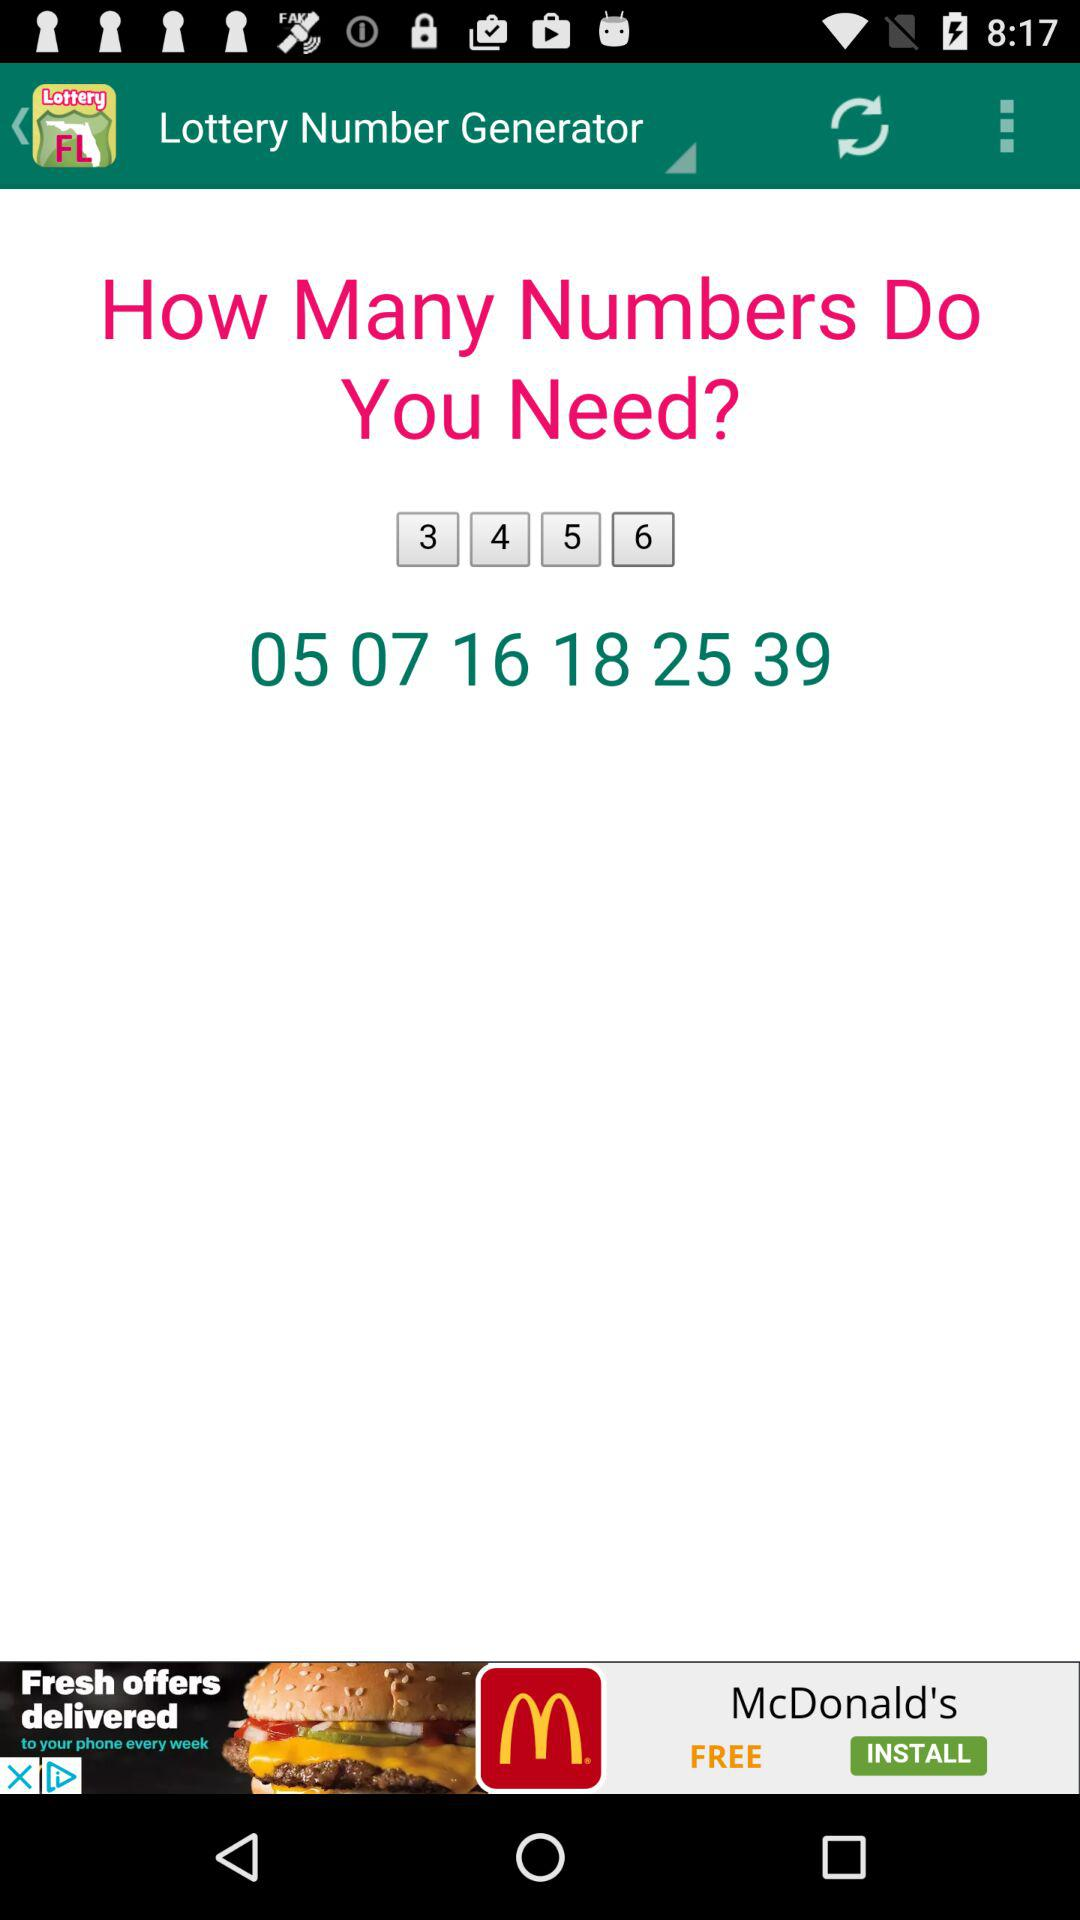How many numbers do you need to generate?
Answer the question using a single word or phrase. 6 